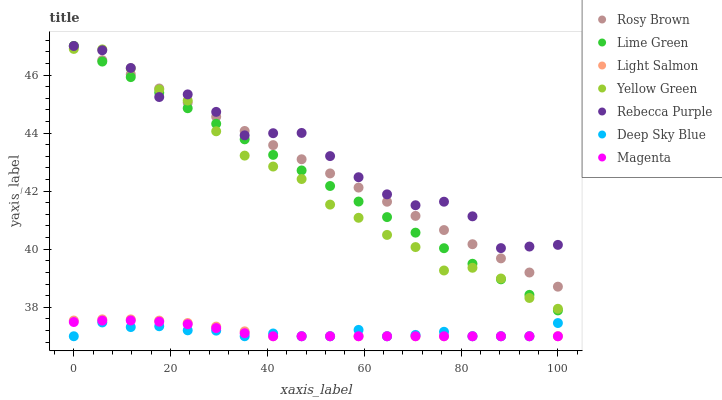Does Deep Sky Blue have the minimum area under the curve?
Answer yes or no. Yes. Does Rebecca Purple have the maximum area under the curve?
Answer yes or no. Yes. Does Yellow Green have the minimum area under the curve?
Answer yes or no. No. Does Yellow Green have the maximum area under the curve?
Answer yes or no. No. Is Lime Green the smoothest?
Answer yes or no. Yes. Is Rebecca Purple the roughest?
Answer yes or no. Yes. Is Yellow Green the smoothest?
Answer yes or no. No. Is Yellow Green the roughest?
Answer yes or no. No. Does Light Salmon have the lowest value?
Answer yes or no. Yes. Does Yellow Green have the lowest value?
Answer yes or no. No. Does Lime Green have the highest value?
Answer yes or no. Yes. Does Yellow Green have the highest value?
Answer yes or no. No. Is Magenta less than Rebecca Purple?
Answer yes or no. Yes. Is Lime Green greater than Deep Sky Blue?
Answer yes or no. Yes. Does Magenta intersect Deep Sky Blue?
Answer yes or no. Yes. Is Magenta less than Deep Sky Blue?
Answer yes or no. No. Is Magenta greater than Deep Sky Blue?
Answer yes or no. No. Does Magenta intersect Rebecca Purple?
Answer yes or no. No. 